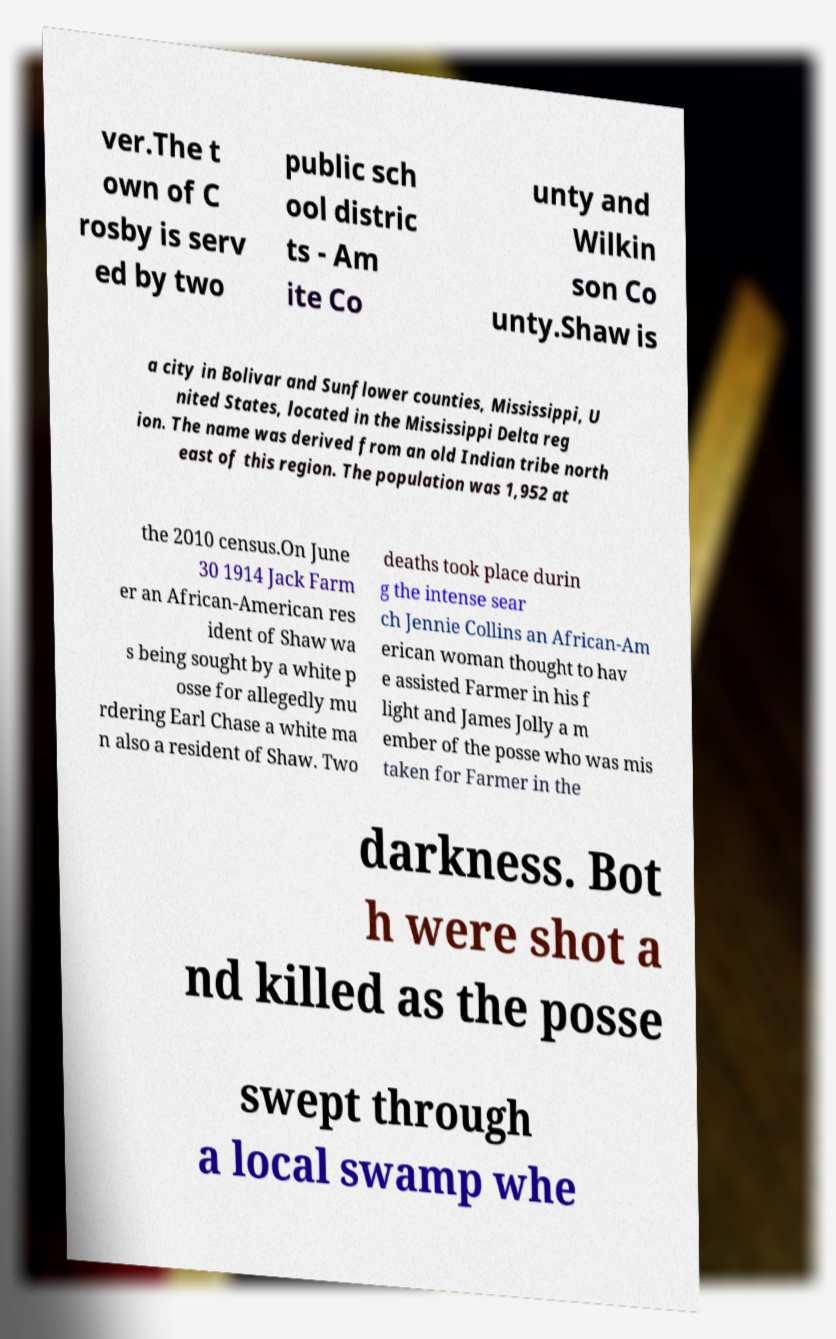Could you assist in decoding the text presented in this image and type it out clearly? ver.The t own of C rosby is serv ed by two public sch ool distric ts - Am ite Co unty and Wilkin son Co unty.Shaw is a city in Bolivar and Sunflower counties, Mississippi, U nited States, located in the Mississippi Delta reg ion. The name was derived from an old Indian tribe north east of this region. The population was 1,952 at the 2010 census.On June 30 1914 Jack Farm er an African-American res ident of Shaw wa s being sought by a white p osse for allegedly mu rdering Earl Chase a white ma n also a resident of Shaw. Two deaths took place durin g the intense sear ch Jennie Collins an African-Am erican woman thought to hav e assisted Farmer in his f light and James Jolly a m ember of the posse who was mis taken for Farmer in the darkness. Bot h were shot a nd killed as the posse swept through a local swamp whe 